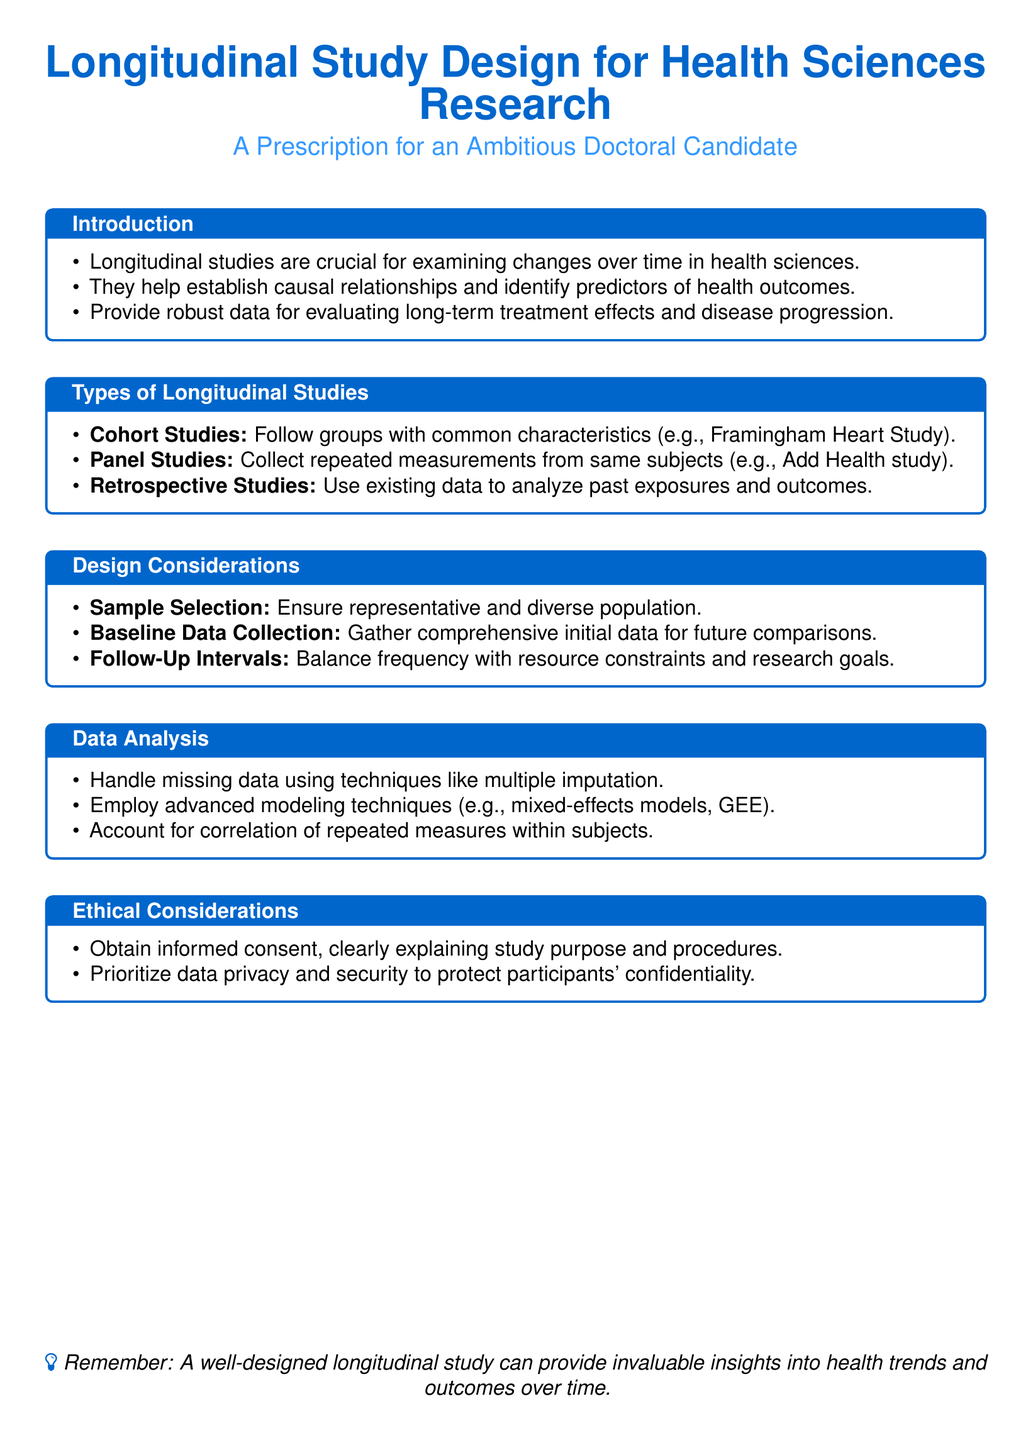what is the main color used in the document? The main color used in the document is specified in the design elements, which is a shade of blue with RGB values of 0, 102, 204.
Answer: blue what type of longitudinal study collects repeated measurements? The type of longitudinal study that collects repeated measurements from the same subjects is identified as panel studies.
Answer: panel studies what is a key design consideration for longitudinal studies? A key design consideration mentioned in the document is the need for sample selection to ensure representative and diverse population.
Answer: sample selection which modeling techniques are recommended for data analysis? Recommended modeling techniques for data analysis include mixed-effects models and generalized estimating equations (GEE).
Answer: mixed-effects models what ethical element is emphasized in the study design? The ethical element emphasized in the study design revolves around obtaining informed consent from participants while explaining study purpose and procedures.
Answer: informed consent how do longitudinal studies benefit health sciences? Longitudinal studies benefit health sciences by helping to establish causal relationships and identify predictors of health outcomes over time.
Answer: establish causal relationships what is the title of this document? The title of the document presents the main focus discussing longitudinal study design for health sciences research targeted at doctoral candidates.
Answer: Longitudinal Study Design for Health Sciences Research what is the purpose of baseline data collection? The purpose of baseline data collection is to gather comprehensive initial data for future comparisons in the study.
Answer: comprehensive initial data how should missing data be handled according to the document? Missing data should be handled using techniques mentioned in the document, specifically multiple imputation.
Answer: multiple imputation 